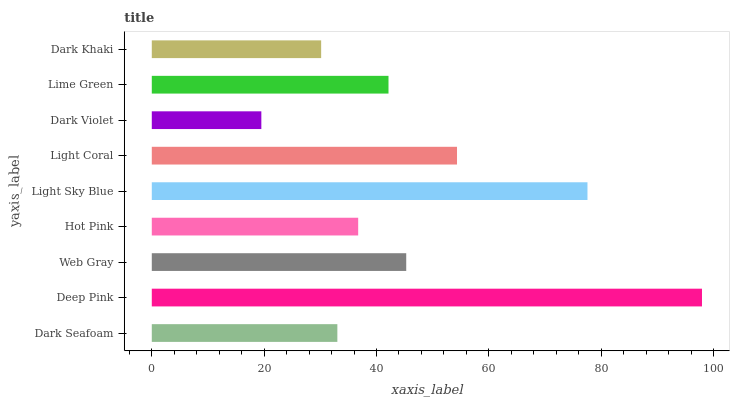Is Dark Violet the minimum?
Answer yes or no. Yes. Is Deep Pink the maximum?
Answer yes or no. Yes. Is Web Gray the minimum?
Answer yes or no. No. Is Web Gray the maximum?
Answer yes or no. No. Is Deep Pink greater than Web Gray?
Answer yes or no. Yes. Is Web Gray less than Deep Pink?
Answer yes or no. Yes. Is Web Gray greater than Deep Pink?
Answer yes or no. No. Is Deep Pink less than Web Gray?
Answer yes or no. No. Is Lime Green the high median?
Answer yes or no. Yes. Is Lime Green the low median?
Answer yes or no. Yes. Is Deep Pink the high median?
Answer yes or no. No. Is Dark Khaki the low median?
Answer yes or no. No. 